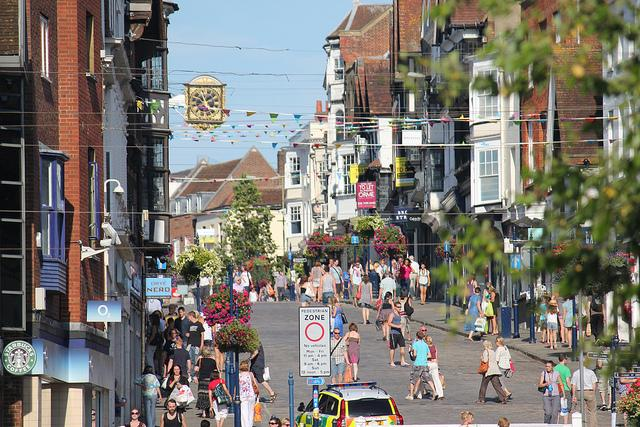What setting is this? city 